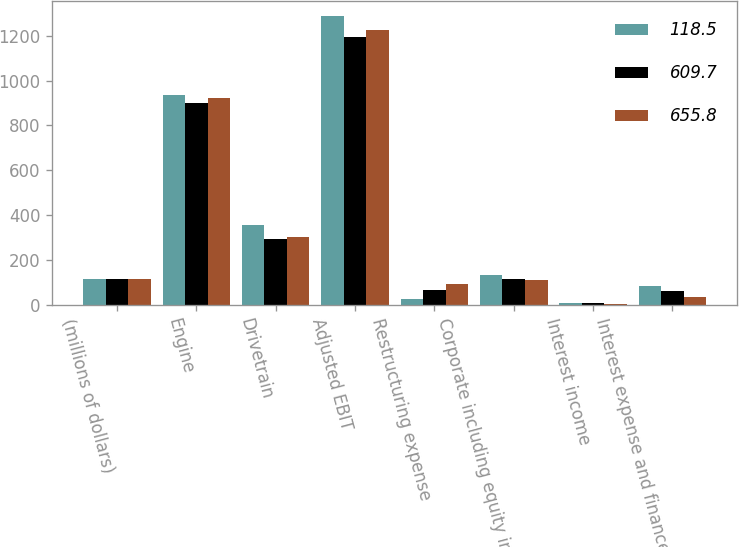Convert chart. <chart><loc_0><loc_0><loc_500><loc_500><stacked_bar_chart><ecel><fcel>(millions of dollars)<fcel>Engine<fcel>Drivetrain<fcel>Adjusted EBIT<fcel>Restructuring expense<fcel>Corporate including equity in<fcel>Interest income<fcel>Interest expense and finance<nl><fcel>118.5<fcel>113.2<fcel>934.1<fcel>354.5<fcel>1288.6<fcel>26.9<fcel>132.1<fcel>6.3<fcel>84.6<nl><fcel>609.7<fcel>113.2<fcel>900.7<fcel>294.6<fcel>1195.3<fcel>65.7<fcel>113.2<fcel>7.5<fcel>60.4<nl><fcel>655.8<fcel>113.2<fcel>924<fcel>303.3<fcel>1227.3<fcel>90.8<fcel>112.1<fcel>5.5<fcel>36.4<nl></chart> 